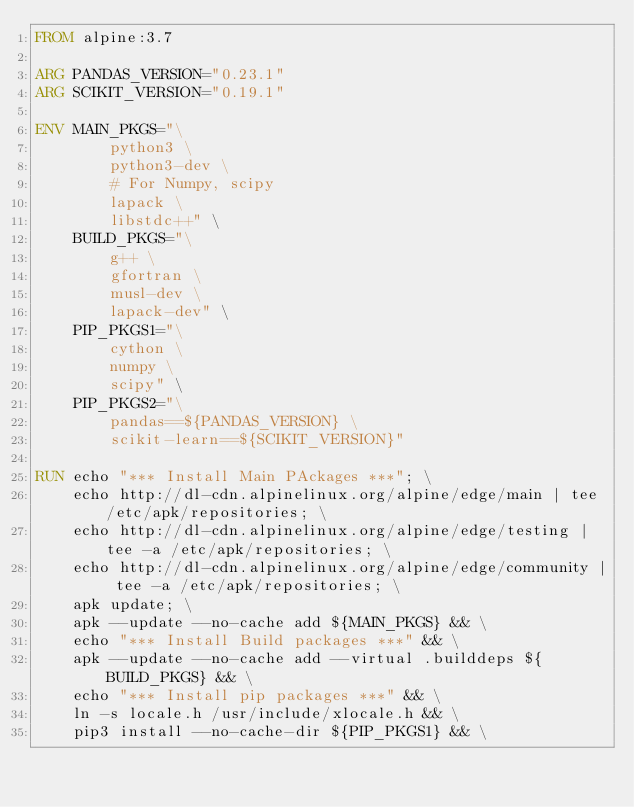Convert code to text. <code><loc_0><loc_0><loc_500><loc_500><_Dockerfile_>FROM alpine:3.7

ARG PANDAS_VERSION="0.23.1"
ARG SCIKIT_VERSION="0.19.1"

ENV MAIN_PKGS="\
        python3 \
        python3-dev \
        # For Numpy, scipy
        lapack \
        libstdc++" \
    BUILD_PKGS="\
        g++ \
        gfortran \
        musl-dev \
        lapack-dev" \
    PIP_PKGS1="\
        cython \
        numpy \
        scipy" \
    PIP_PKGS2="\
        pandas==${PANDAS_VERSION} \
        scikit-learn==${SCIKIT_VERSION}" 

RUN echo "*** Install Main PAckages ***"; \
    echo http://dl-cdn.alpinelinux.org/alpine/edge/main | tee /etc/apk/repositories; \
    echo http://dl-cdn.alpinelinux.org/alpine/edge/testing | tee -a /etc/apk/repositories; \
    echo http://dl-cdn.alpinelinux.org/alpine/edge/community | tee -a /etc/apk/repositories; \
    apk update; \
    apk --update --no-cache add ${MAIN_PKGS} && \
    echo "*** Install Build packages ***" && \
    apk --update --no-cache add --virtual .builddeps ${BUILD_PKGS} && \
    echo "*** Install pip packages ***" && \
    ln -s locale.h /usr/include/xlocale.h && \
    pip3 install --no-cache-dir ${PIP_PKGS1} && \</code> 